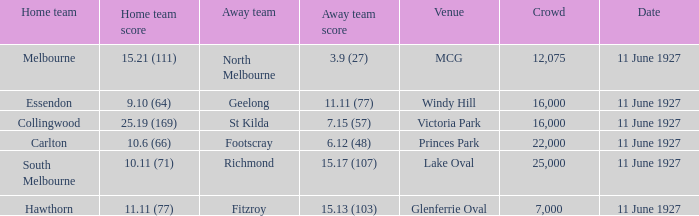Which home team competed against the away team Geelong? Essendon. 